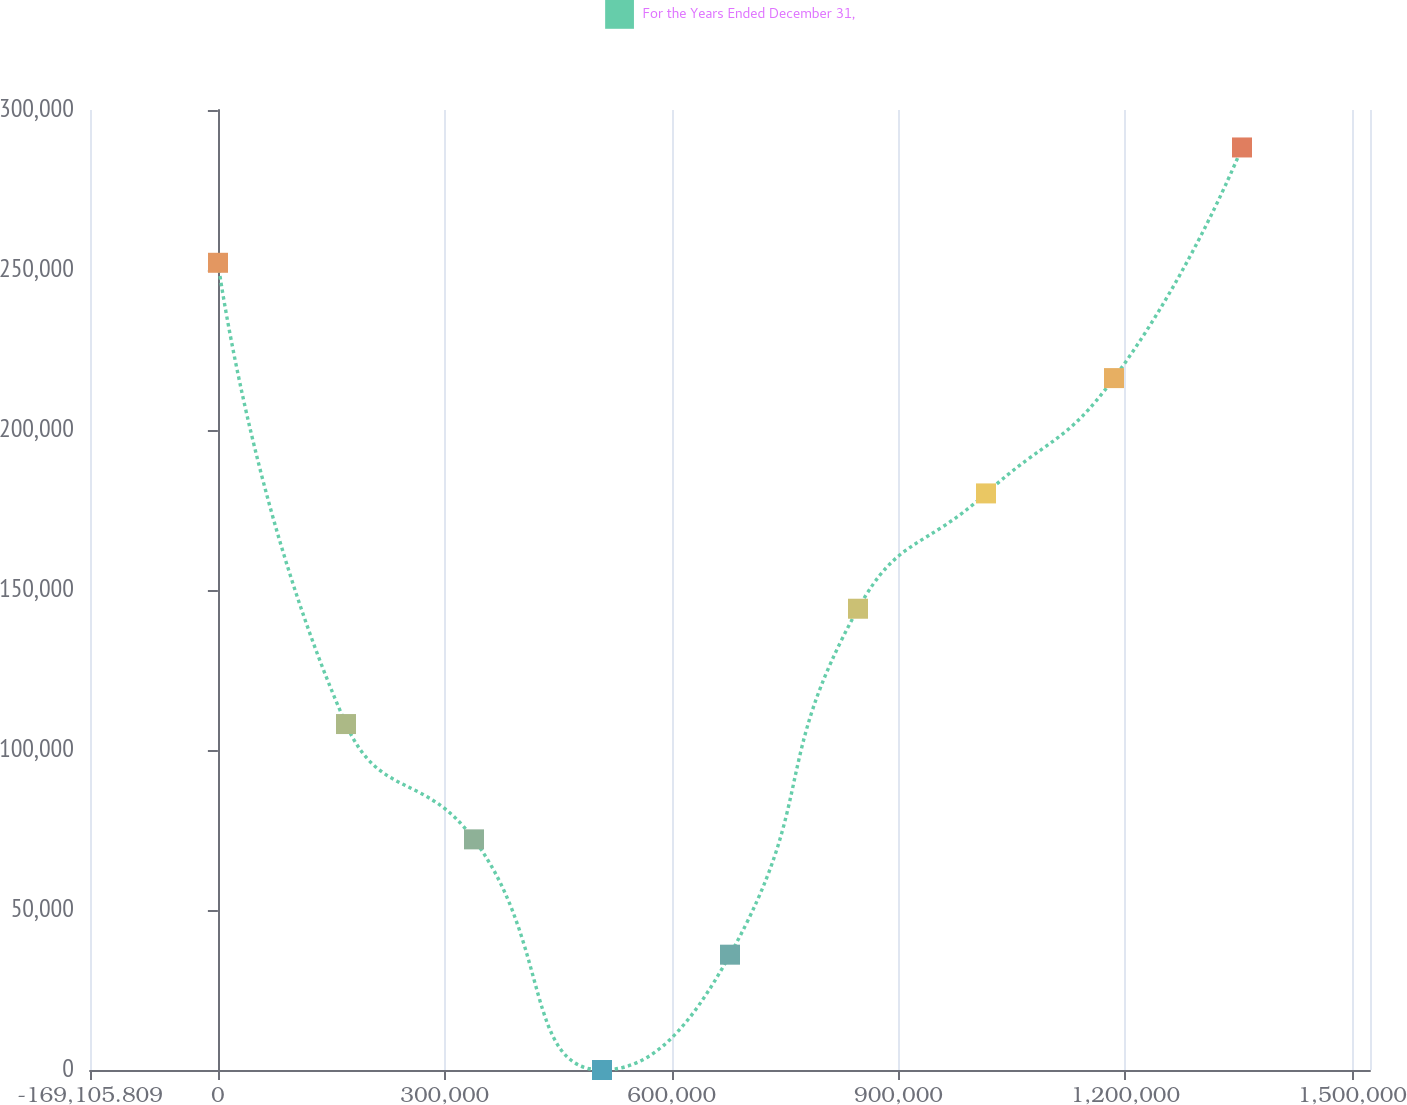Convert chart. <chart><loc_0><loc_0><loc_500><loc_500><line_chart><ecel><fcel>For the Years Ended December 31,<nl><fcel>159.14<fcel>252255<nl><fcel>169424<fcel>108110<nl><fcel>338689<fcel>72073.7<nl><fcel>507954<fcel>1.25<nl><fcel>677219<fcel>36037.5<nl><fcel>846484<fcel>144146<nl><fcel>1.01575e+06<fcel>180182<nl><fcel>1.18501e+06<fcel>216219<nl><fcel>1.35428e+06<fcel>288291<nl><fcel>1.69281e+06<fcel>360363<nl></chart> 